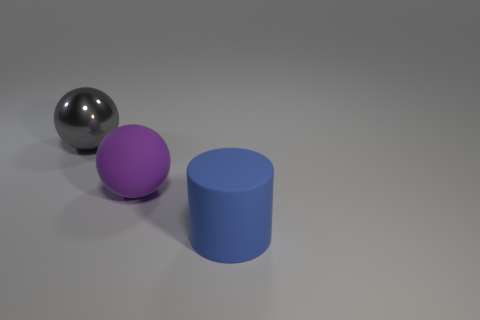Does the gray thing have the same material as the thing on the right side of the large purple rubber thing?
Your response must be concise. No. There is a large sphere to the right of the large gray metallic ball; what is its material?
Provide a succinct answer. Rubber. What is the size of the metal ball?
Your answer should be compact. Large. There is a ball that is right of the big gray shiny thing; is it the same size as the ball behind the large purple thing?
Offer a terse response. Yes. What is the size of the gray metal object that is the same shape as the large purple rubber object?
Offer a terse response. Large. Do the purple matte sphere and the rubber object that is in front of the large purple matte ball have the same size?
Your answer should be very brief. Yes. Are there any large gray metal things in front of the matte thing that is behind the big blue thing?
Provide a succinct answer. No. What is the shape of the big blue object that is in front of the big purple rubber object?
Keep it short and to the point. Cylinder. There is a ball left of the large ball that is in front of the gray metal ball; what color is it?
Ensure brevity in your answer.  Gray. Is the metal thing the same size as the blue matte cylinder?
Make the answer very short. Yes. 